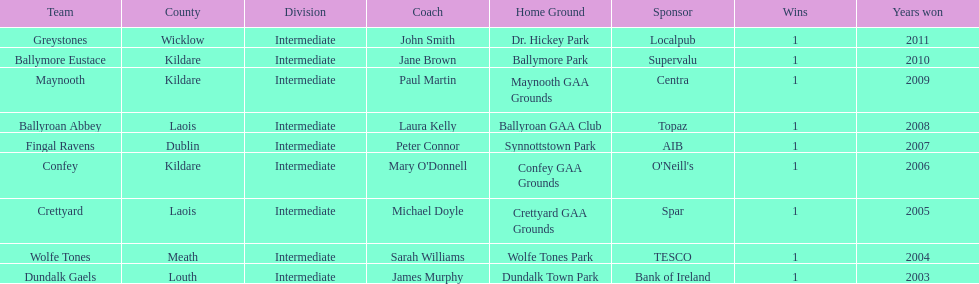What county is the team that won in 2009 from? Kildare. What is the teams name? Maynooth. 